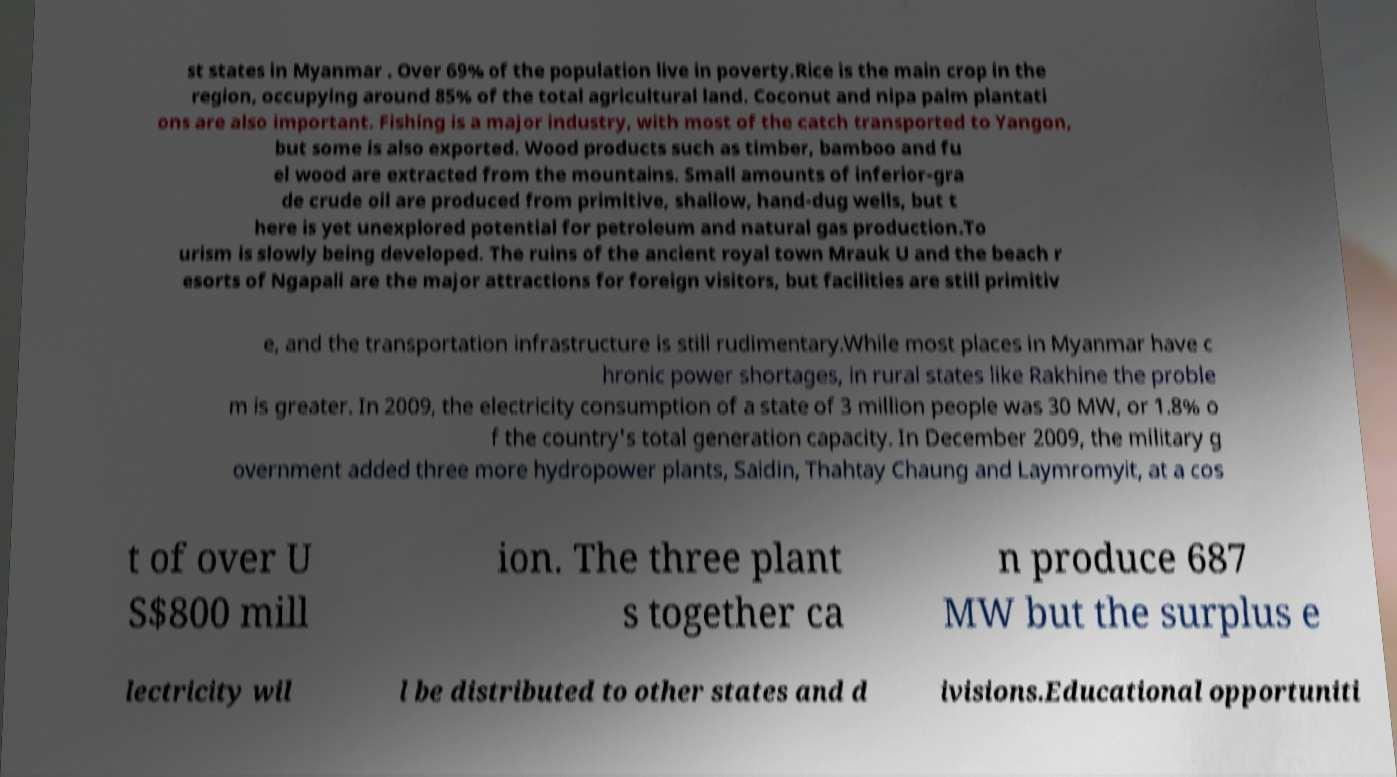Can you accurately transcribe the text from the provided image for me? st states in Myanmar . Over 69% of the population live in poverty.Rice is the main crop in the region, occupying around 85% of the total agricultural land. Coconut and nipa palm plantati ons are also important. Fishing is a major industry, with most of the catch transported to Yangon, but some is also exported. Wood products such as timber, bamboo and fu el wood are extracted from the mountains. Small amounts of inferior-gra de crude oil are produced from primitive, shallow, hand-dug wells, but t here is yet unexplored potential for petroleum and natural gas production.To urism is slowly being developed. The ruins of the ancient royal town Mrauk U and the beach r esorts of Ngapali are the major attractions for foreign visitors, but facilities are still primitiv e, and the transportation infrastructure is still rudimentary.While most places in Myanmar have c hronic power shortages, in rural states like Rakhine the proble m is greater. In 2009, the electricity consumption of a state of 3 million people was 30 MW, or 1.8% o f the country's total generation capacity. In December 2009, the military g overnment added three more hydropower plants, Saidin, Thahtay Chaung and Laymromyit, at a cos t of over U S$800 mill ion. The three plant s together ca n produce 687 MW but the surplus e lectricity wil l be distributed to other states and d ivisions.Educational opportuniti 